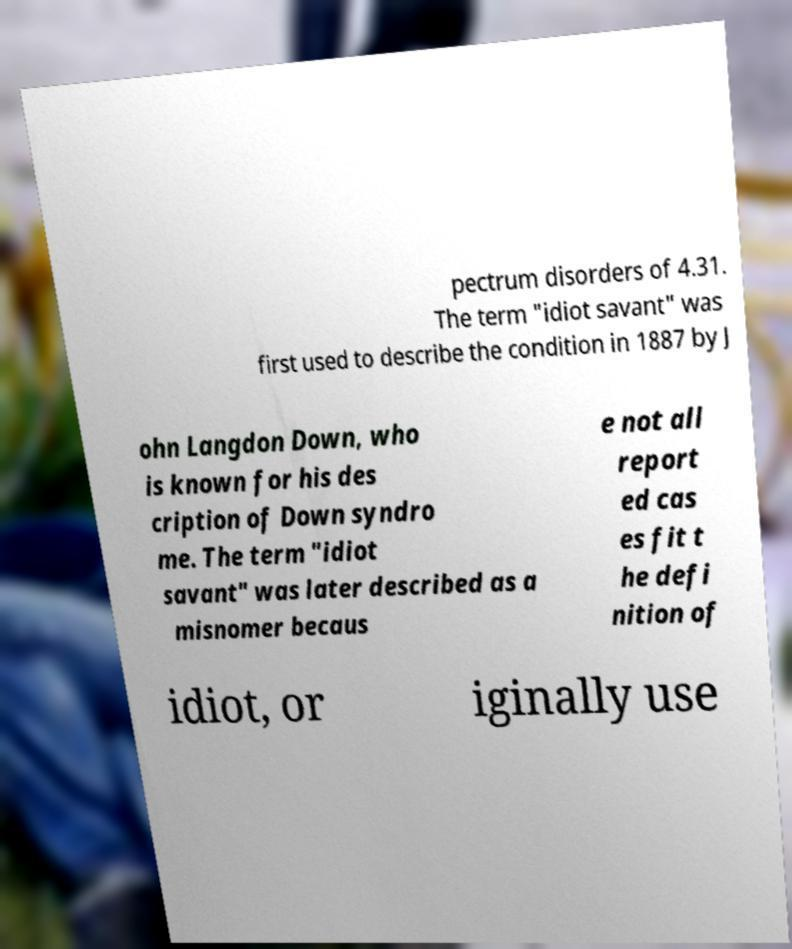Please identify and transcribe the text found in this image. pectrum disorders of 4.31. The term "idiot savant" was first used to describe the condition in 1887 by J ohn Langdon Down, who is known for his des cription of Down syndro me. The term "idiot savant" was later described as a misnomer becaus e not all report ed cas es fit t he defi nition of idiot, or iginally use 